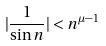Convert formula to latex. <formula><loc_0><loc_0><loc_500><loc_500>| \frac { 1 } { \sin n } | < n ^ { \mu - 1 }</formula> 